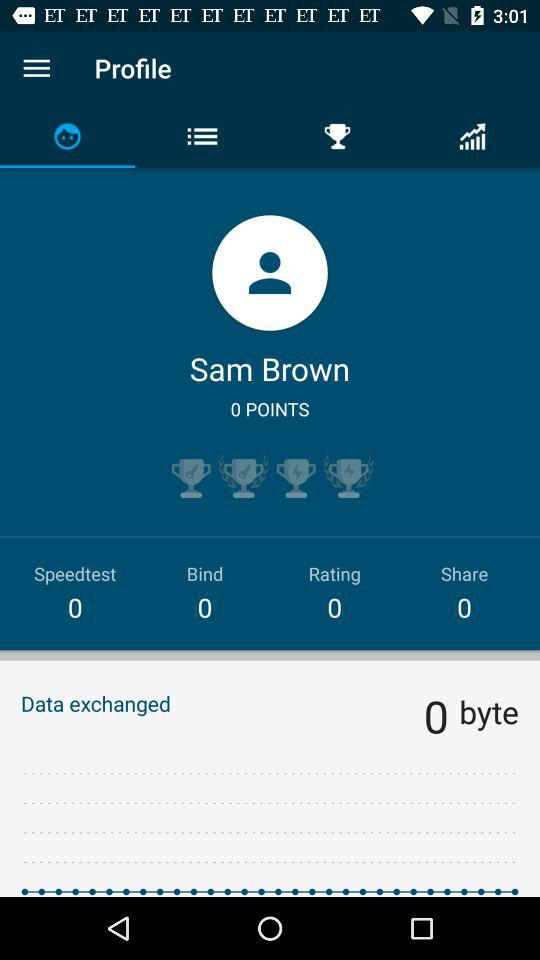How many points does Sam Brown have?
Answer the question using a single word or phrase. 0 